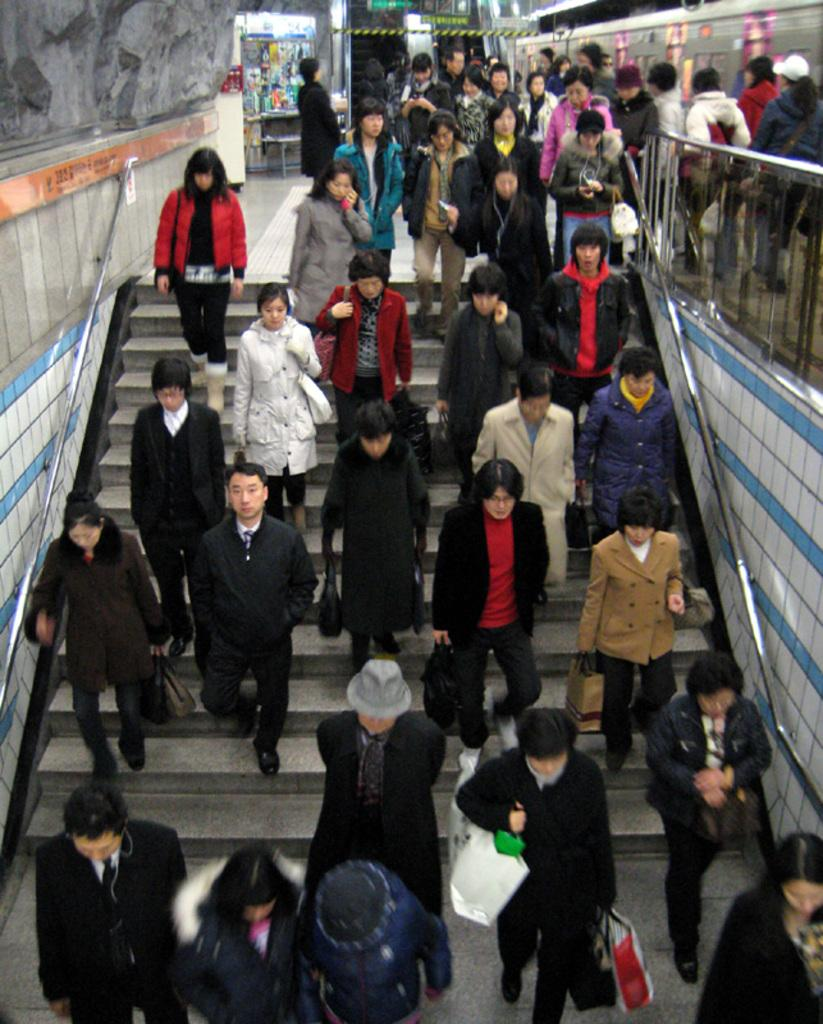What is the main subject of the image? The main subject of the image is a crowd. Where is the crowd located? The crowd is on a platform. What are many people in the crowd doing? Many people in the crowd are getting down the stairs. How many eggs are being carried by the donkey in the image? There is no donkey or eggs present in the image. What type of harmony is being played by the crowd in the image? There is no indication of music or harmony in the image; it simply shows a crowd on a platform. 